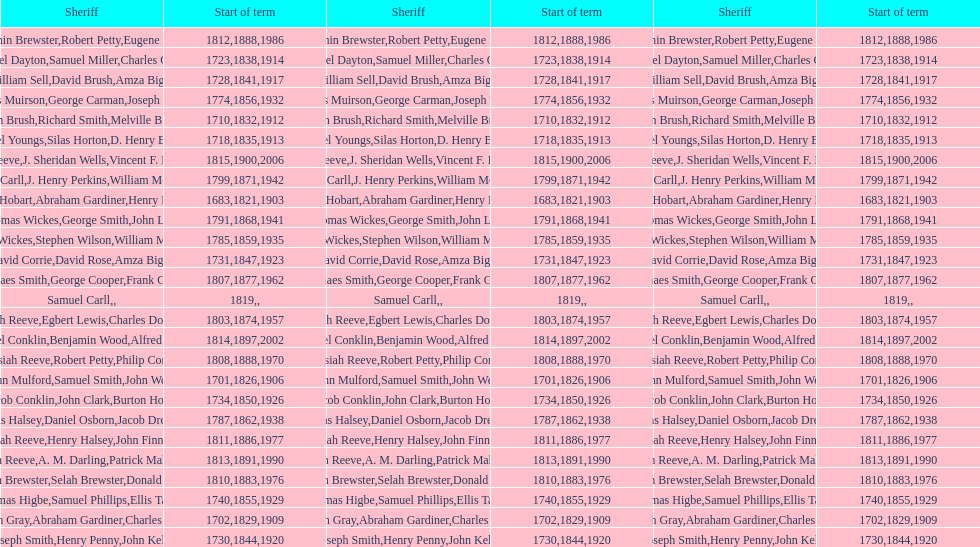How sheriffs has suffolk county had in total? 76. Parse the table in full. {'header': ['Sheriff', 'Start of term', 'Sheriff', 'Start of term', 'Sheriff', 'Start of term'], 'rows': [['Benjamin Brewster', '1812', 'Robert Petty', '1888', 'Eugene Dooley', '1986'], ['Samuel Dayton', '1723', 'Samuel Miller', '1838', "Charles O'Dell", '1914'], ['William Sell', '1728', 'David Brush', '1841', 'Amza Biggs', '1917'], ['James Muirson', '1774', 'George Carman', '1856', 'Joseph Warta', '1932'], ['John Brush', '1710', 'Richard Smith', '1832', 'Melville Brush', '1912'], ['Daniel Youngs', '1718', 'Silas Horton', '1835', 'D. Henry Brown', '1913'], ['Josiah Reeve', '1815', 'J. Sheridan Wells', '1900', 'Vincent F. DeMarco', '2006'], ['Phinaes Carll', '1799', 'J. Henry Perkins', '1871', 'William McCollom', '1942'], ['Josiah Hobart', '1683', 'Abraham Gardiner', '1821', 'Henry Preston', '1903'], ['Thomas Wickes', '1791', 'George Smith', '1868', 'John Levy', '1941'], ['Thomas Wickes', '1785', 'Stephen Wilson', '1859', 'William McCollom', '1935'], ['David Corrie', '1731', 'David Rose', '1847', 'Amza Biggs', '1923'], ['Phinaes Smith', '1807', 'George Cooper', '1877', 'Frank Gross', '1962'], ['Samuel Carll', '1819', '', '', '', ''], ['Josiah Reeve', '1803', 'Egbert Lewis', '1874', 'Charles Dominy', '1957'], ['Nathaniel Conklin', '1814', 'Benjamin Wood', '1897', 'Alfred C. Tisch', '2002'], ['Josiah Reeve', '1808', 'Robert Petty', '1888', 'Philip Corso', '1970'], ['John Mulford', '1701', 'Samuel Smith', '1826', 'John Wells', '1906'], ['Jacob Conklin', '1734', 'John Clark', '1850', 'Burton Howe', '1926'], ['Silas Halsey', '1787', 'Daniel Osborn', '1862', 'Jacob Dreyer', '1938'], ['Josiah Reeve', '1811', 'Henry Halsey', '1886', 'John Finnerty', '1977'], ['Josiah Reeve', '1813', 'A. M. Darling', '1891', 'Patrick Mahoney', '1990'], ['Benjamin Brewster', '1810', 'Selah Brewster', '1883', 'Donald Dilworth', '1976'], ['Thomas Higbe', '1740', 'Samuel Phillips', '1855', 'Ellis Taylor', '1929'], ['Hugh Gray', '1702', 'Abraham Gardiner', '1829', 'Charles Platt', '1909'], ['Joseph Smith', '1730', 'Henry Penny', '1844', 'John Kelly', '1920']]} 